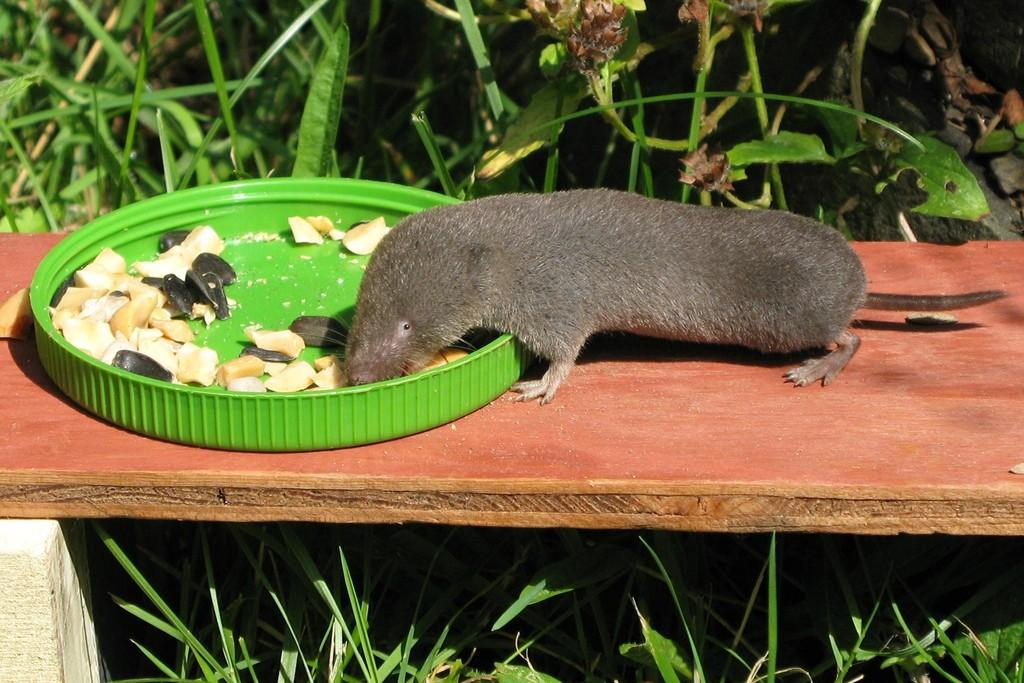What type of animal is in the image? There is an animal in the image, but the specific type cannot be determined from the provided facts. What is the color of the surface the animal is on? The animal is on a brown surface. What is the color of the plate in the image? The plate is green. What can be seen in the background of the image? There are plants in the background of the image. What is the color of the plants in the image? The plants are green. What type of hammer is being used by the animal in the image? There is no hammer present in the image; it only features an animal, a brown surface, a green plate, and plants in the background. 